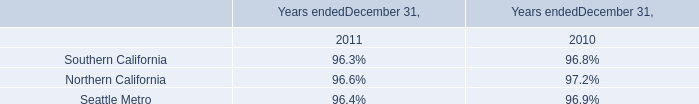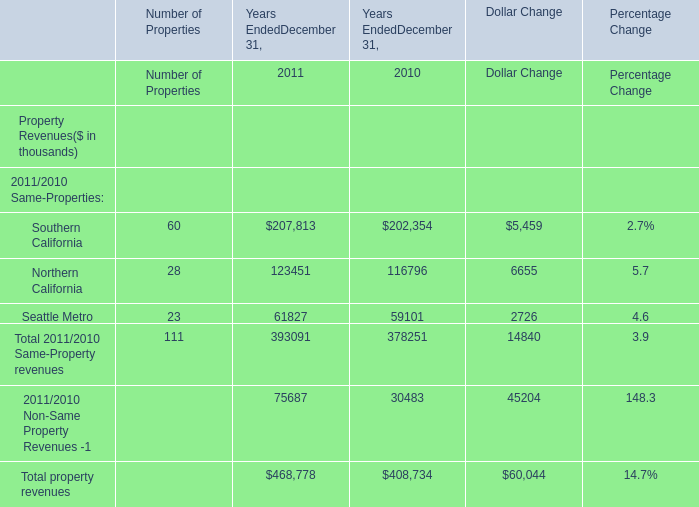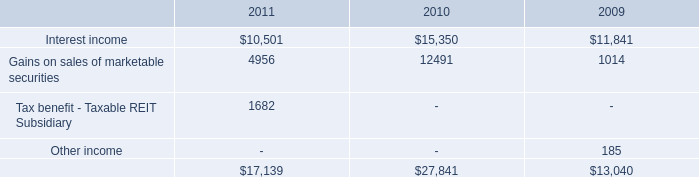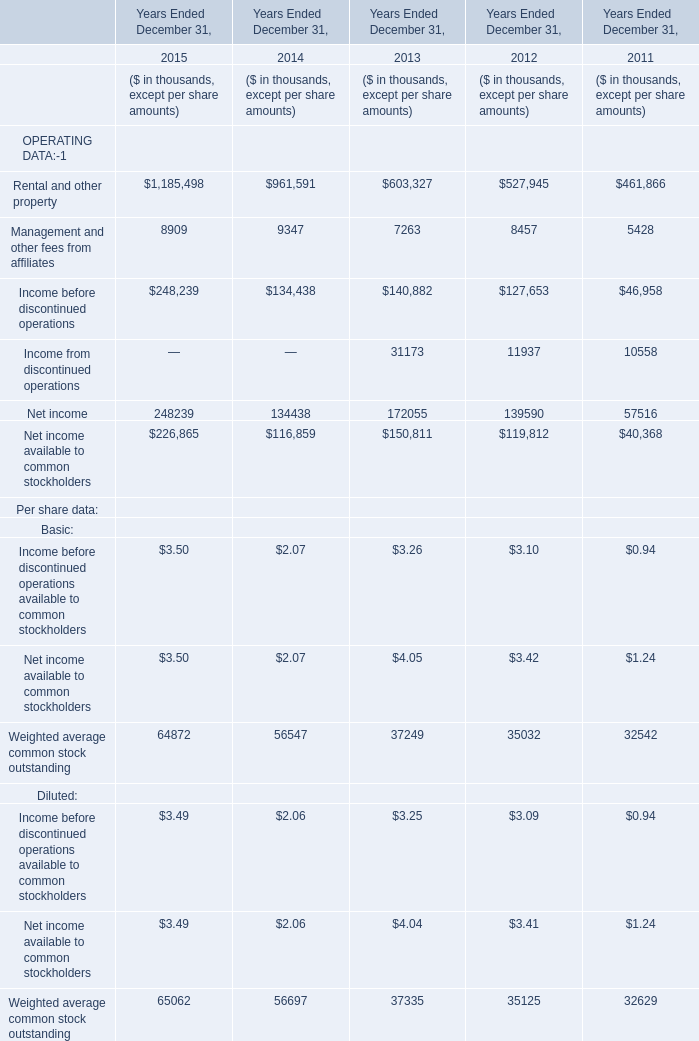What's the sum of Interest income of 2010, and Southern California of Years EndedDecember 31, 2010 ? 
Computations: (15350.0 + 202354.0)
Answer: 217704.0. 